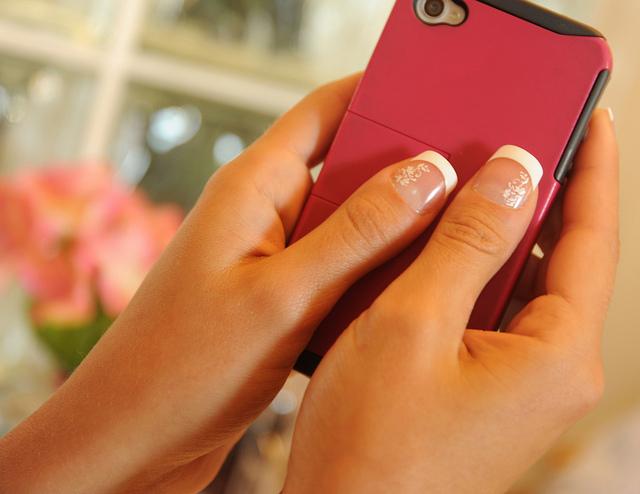How many hands do you see?
Quick response, please. 2. Is the person wearing nail polish?
Concise answer only. Yes. Is there nail polish on the nail?
Give a very brief answer. Yes. What color are the flowers in the background?
Concise answer only. Pink. Is the person wearing a ring?
Short answer required. No. What color is the girl's nails?
Answer briefly. White. What is the person typing on?
Short answer required. Cell phone. Do the hands belong to male or female?
Write a very short answer. Female. What color is the phone?
Concise answer only. Red. 